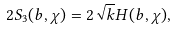<formula> <loc_0><loc_0><loc_500><loc_500>2 S _ { 3 } ( b , \chi ) = 2 \sqrt { k } H ( b , \chi ) ,</formula> 